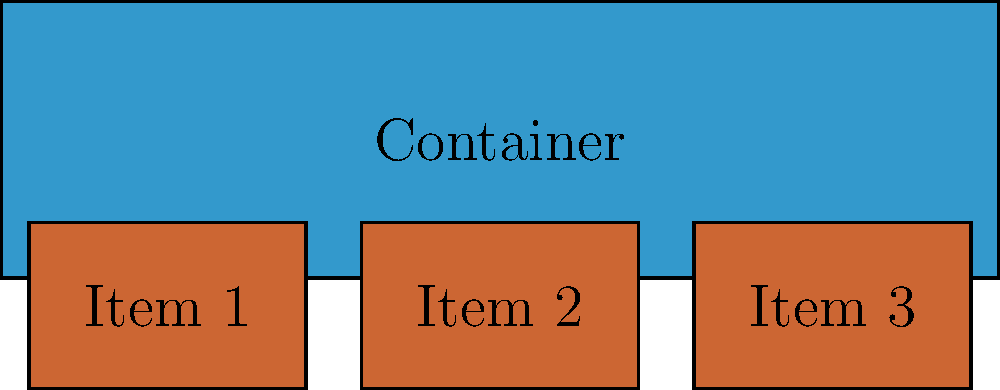Given the component arrangement shown in the image, which CSS flexbox properties should be applied to the container to achieve this layout? To determine the correct CSS flexbox properties for this layout, let's analyze the component arrangement step-by-step:

1. The container (blue rectangle) spans the full width of the available space.
2. The three items (orange rectangles) are positioned horizontally within the container.
3. The items are evenly spaced across the width of the container.
4. The items are aligned to the bottom of the container.

Based on these observations, we can conclude:

1. The container should use `display: flex` to enable flexbox layout.
2. `flex-direction: row` should be used (this is the default, so it's not necessary to specify explicitly).
3. To evenly space the items, we need `justify-content: space-between`.
4. To align the items to the bottom of the container, we use `align-items: flex-end`.

Therefore, the CSS properties for the container should be:

```css
.container {
  display: flex;
  justify-content: space-between;
  align-items: flex-end;
}
```

This combination of flexbox properties will create the layout shown in the image.
Answer: display: flex; justify-content: space-between; align-items: flex-end; 